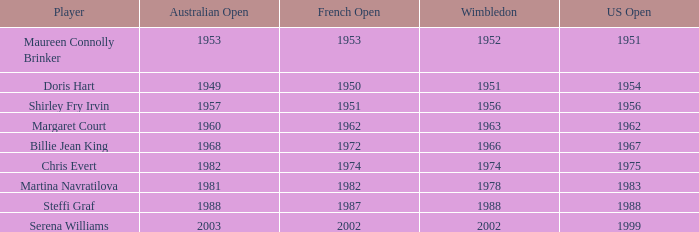What year did martina navratilova achieve success at wimbledon? 1978.0. Could you help me parse every detail presented in this table? {'header': ['Player', 'Australian Open', 'French Open', 'Wimbledon', 'US Open'], 'rows': [['Maureen Connolly Brinker', '1953', '1953', '1952', '1951'], ['Doris Hart', '1949', '1950', '1951', '1954'], ['Shirley Fry Irvin', '1957', '1951', '1956', '1956'], ['Margaret Court', '1960', '1962', '1963', '1962'], ['Billie Jean King', '1968', '1972', '1966', '1967'], ['Chris Evert', '1982', '1974', '1974', '1975'], ['Martina Navratilova', '1981', '1982', '1978', '1983'], ['Steffi Graf', '1988', '1987', '1988', '1988'], ['Serena Williams', '2003', '2002', '2002', '1999']]} 